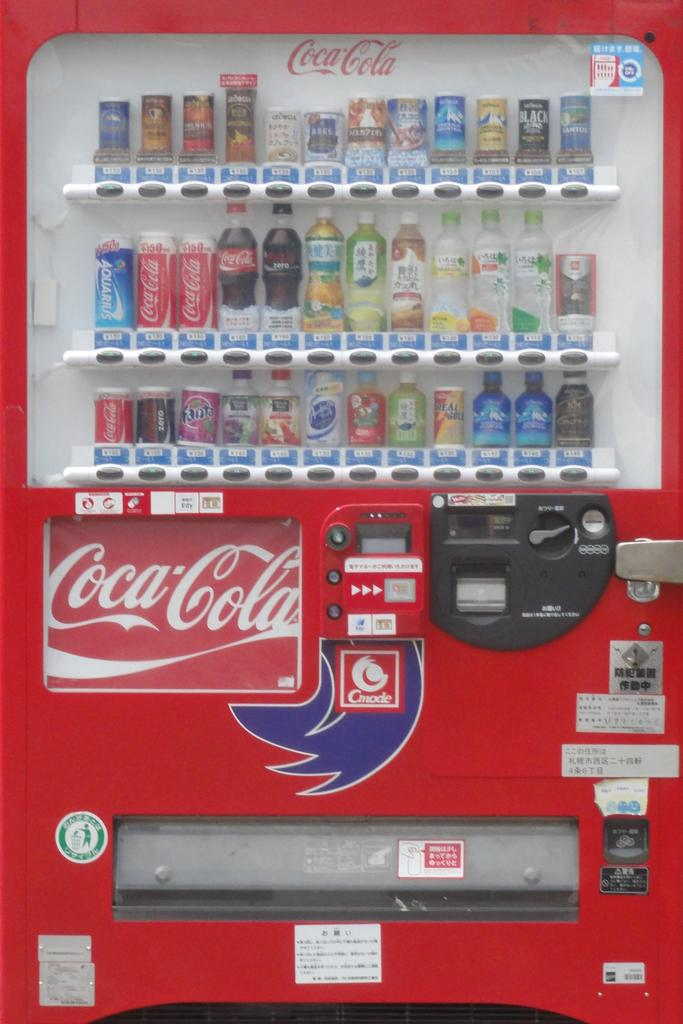<image>
Provide a brief description of the given image. A drink vending machine with the Coca Cola emblem on the front. 